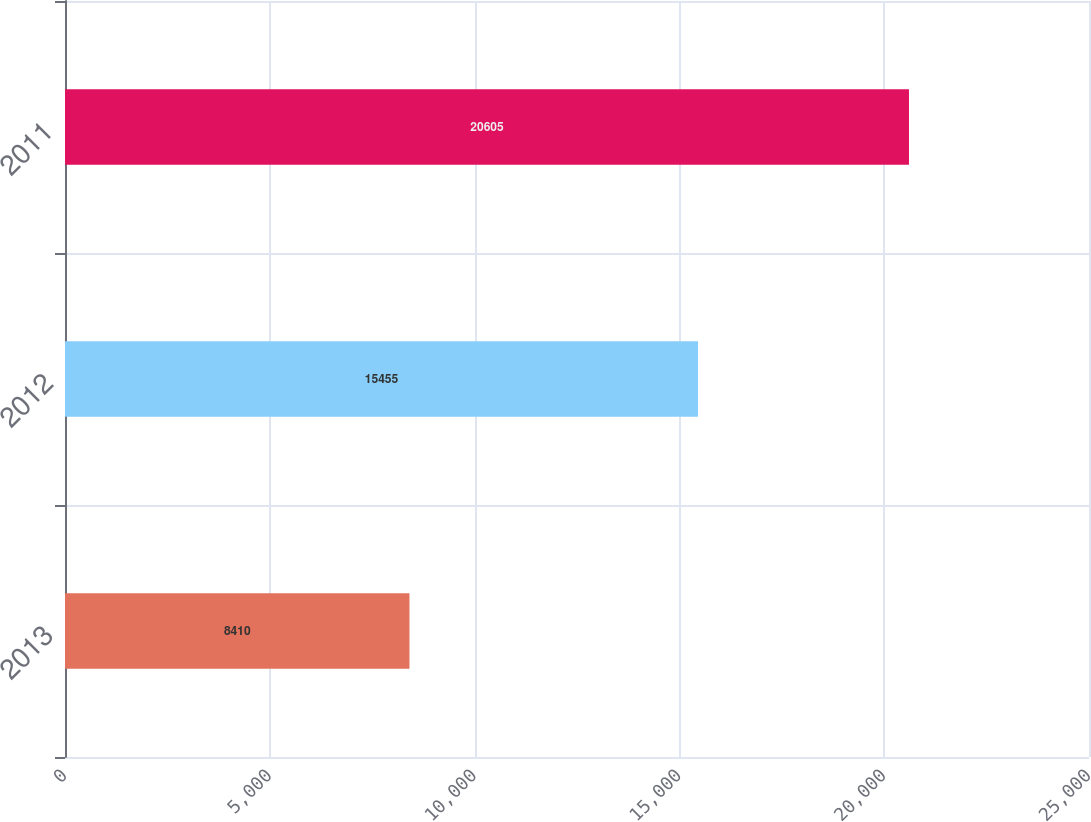<chart> <loc_0><loc_0><loc_500><loc_500><bar_chart><fcel>2013<fcel>2012<fcel>2011<nl><fcel>8410<fcel>15455<fcel>20605<nl></chart> 